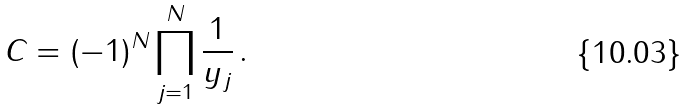<formula> <loc_0><loc_0><loc_500><loc_500>C = ( - 1 ) ^ { N } \prod _ { j = 1 } ^ { N } \frac { 1 } { y _ { j } } \, .</formula> 